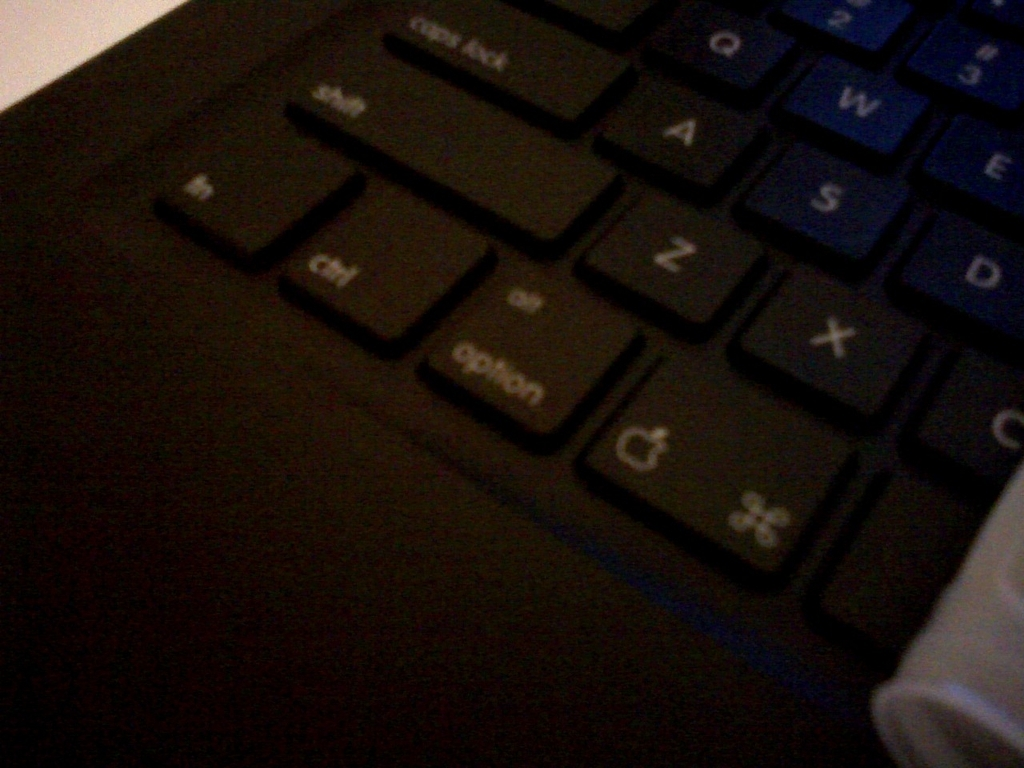Can you describe the condition of the keyboard? The keyboard looks to be in a used condition with signs of wear. Some of the key labels show notable fading, suggesting it has been subject to significant use over time. 